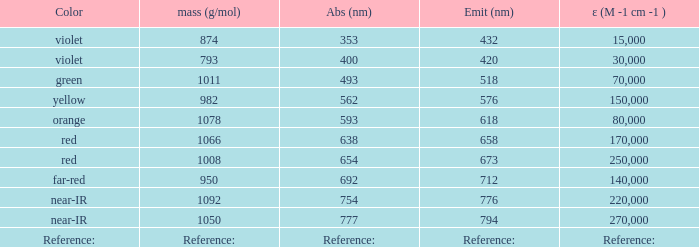Which ε (M -1 cm -1) has a molar mass of 1008 g/mol? 250000.0. 